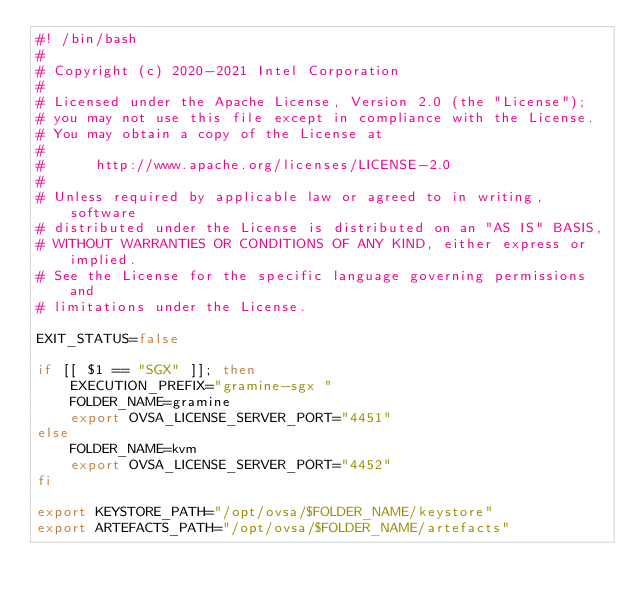<code> <loc_0><loc_0><loc_500><loc_500><_Bash_>#! /bin/bash
#
# Copyright (c) 2020-2021 Intel Corporation
#
# Licensed under the Apache License, Version 2.0 (the "License");
# you may not use this file except in compliance with the License.
# You may obtain a copy of the License at
#
#      http://www.apache.org/licenses/LICENSE-2.0
#
# Unless required by applicable law or agreed to in writing, software
# distributed under the License is distributed on an "AS IS" BASIS,
# WITHOUT WARRANTIES OR CONDITIONS OF ANY KIND, either express or implied.
# See the License for the specific language governing permissions and
# limitations under the License.

EXIT_STATUS=false

if [[ $1 == "SGX" ]]; then
	EXECUTION_PREFIX="gramine-sgx "
	FOLDER_NAME=gramine
	export OVSA_LICENSE_SERVER_PORT="4451"
else
	FOLDER_NAME=kvm
	export OVSA_LICENSE_SERVER_PORT="4452"
fi

export KEYSTORE_PATH="/opt/ovsa/$FOLDER_NAME/keystore"
export ARTEFACTS_PATH="/opt/ovsa/$FOLDER_NAME/artefacts"</code> 